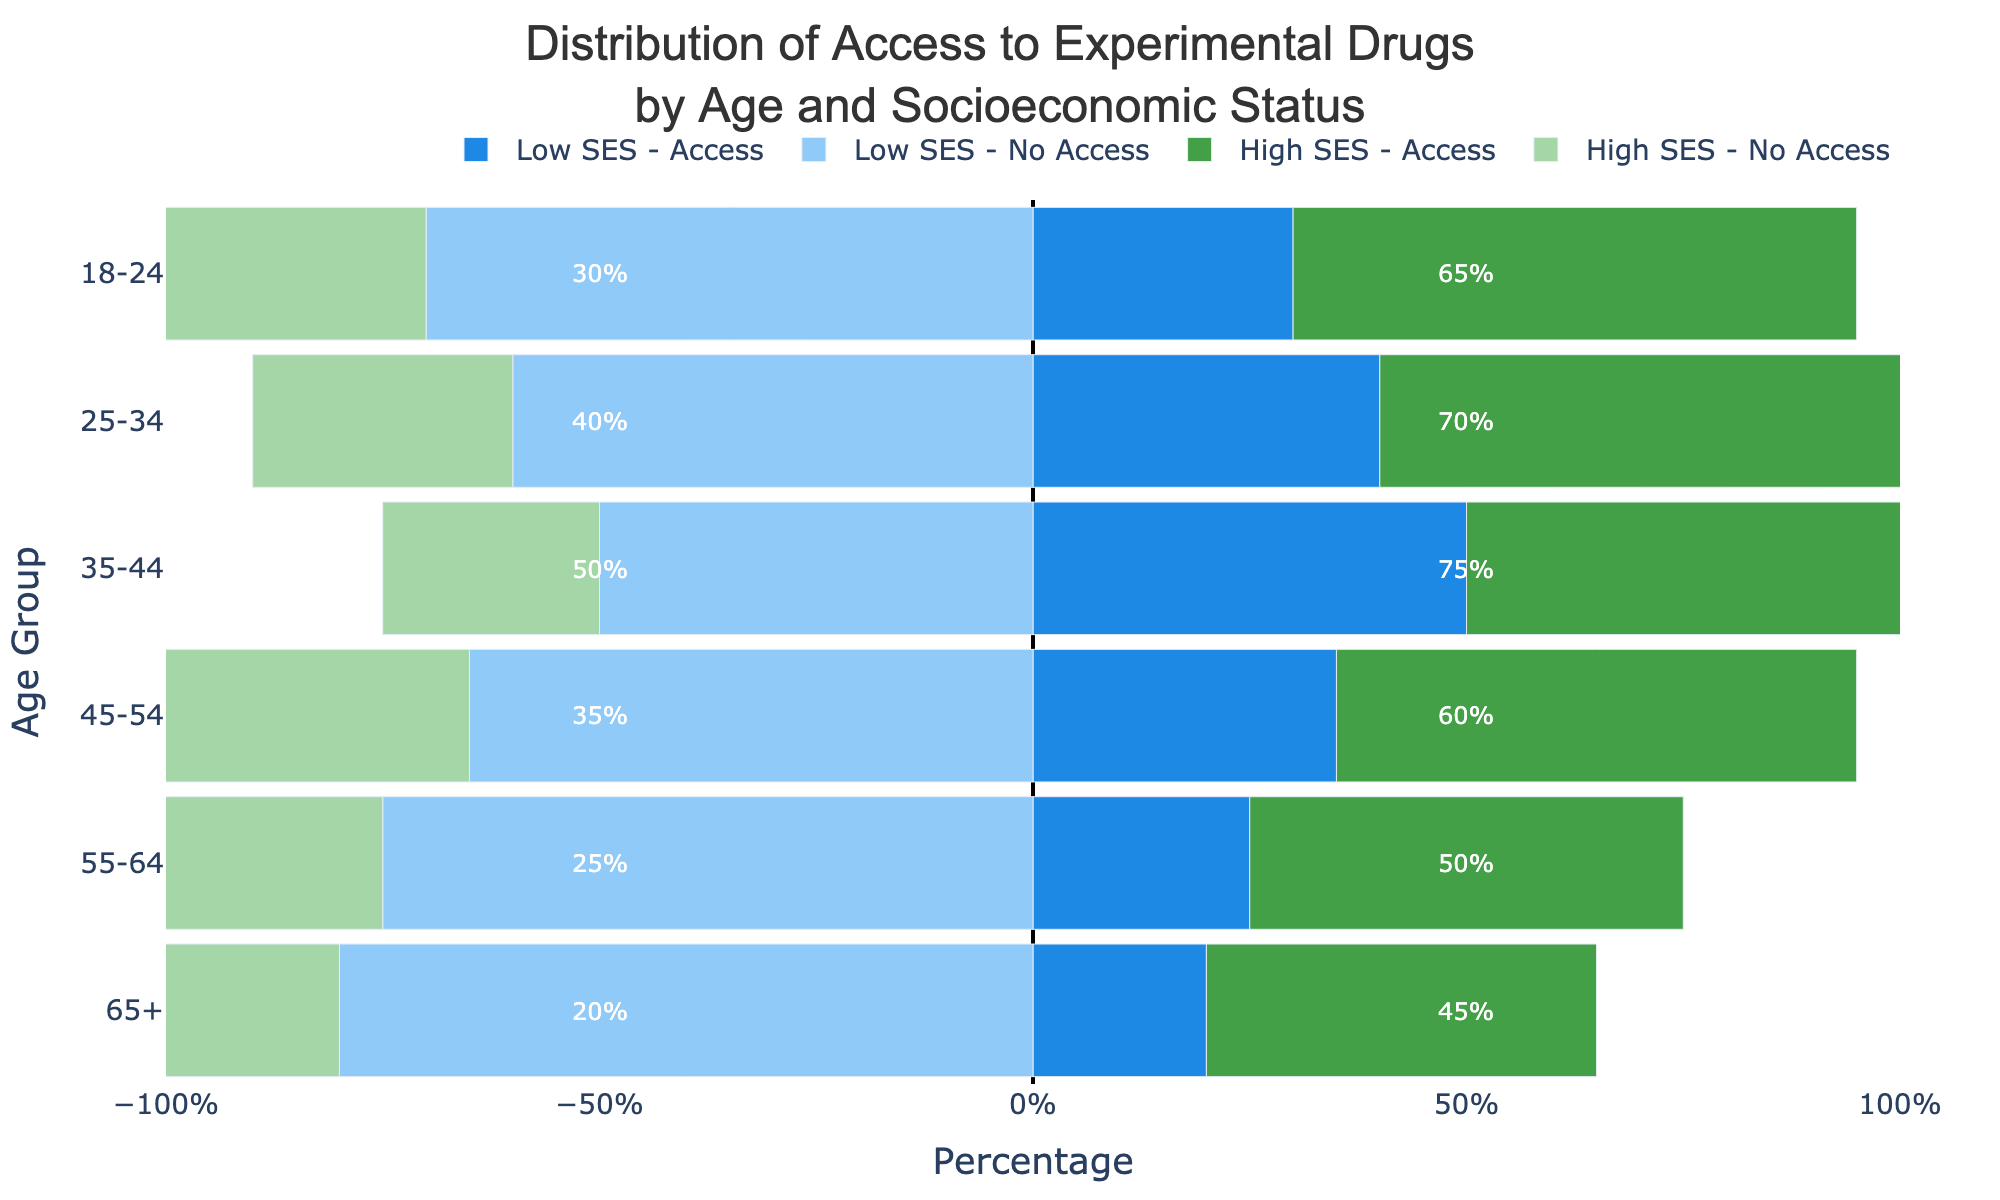What age group exhibits the highest percentage of access to experimental drugs for both low and high socioeconomic statuses? For high socioeconomic status, the group with the highest access percentage is the 35-44 age group (75%). For low socioeconomic status, the group with the highest access percentage is also the 35-44 age group (50%).
Answer: 35-44 Which socioeconomic status group in the 45-54 age range has a higher percentage of access to experimental drugs? In the 45-54 age range, the high socioeconomic status group has a 60% access rate compared to the low socioeconomic status group's 35% access rate.
Answer: High socioeconomic status What is the total percentage of high socioeconomic status individuals aged 18-24 who either have access or do not have access to experimental drugs? The sum of access (65%) and no access (35%) for high socioeconomic status individuals aged 18-24 equals 100%.
Answer: 100% In the 55-64 age group, what is the ratio of access to no access for the high socioeconomic status? For the 55-64 age group, the high socioeconomic status access rate is 50% and the no access rate is also 50%. The ratio is 50:50 or simplified to 1:1.
Answer: 1:1 Which age group has the lowest percentage of access to experimental drugs for low socioeconomic status individuals? The 65+ age group has the lowest access percentage for low socioeconomic status individuals, with 20%.
Answer: 65+ Compare the overall access rates to experimental drugs between low and high socioeconomic statuses across all age groups. Which status has a higher overall access rate? Calculate the overall access rates by averaging the percentages across all age groups:
Low socioeconomic status: (30 + 40 + 50 + 35 + 25 + 20) / 6 = 200/6 ≈ 33.3%
High socioeconomic status: (65 + 70 + 75 + 60 + 50 + 45) / 6 = 365/6 ≈ 60.8%
High socioeconomic status has a higher overall access rate.
Answer: High socioeconomic status What trend do you observe in the access to experimental drugs for low socioeconomic status individuals as the age increases? As the age increases, the access percentage for low socioeconomic status individuals generally decreases from 30% for ages 18-24 to 20% for ages 65+.
Answer: Decreasing trend In the age group 25-34, what percentage more high socioeconomic status individuals have access to experimental drugs compared to low socioeconomic status individuals? High socioeconomic status individuals aged 25-34 have a 70% access rate compared to 40% for low socioeconomic status individuals. The difference is 70% - 40% = 30%.
Answer: 30% 